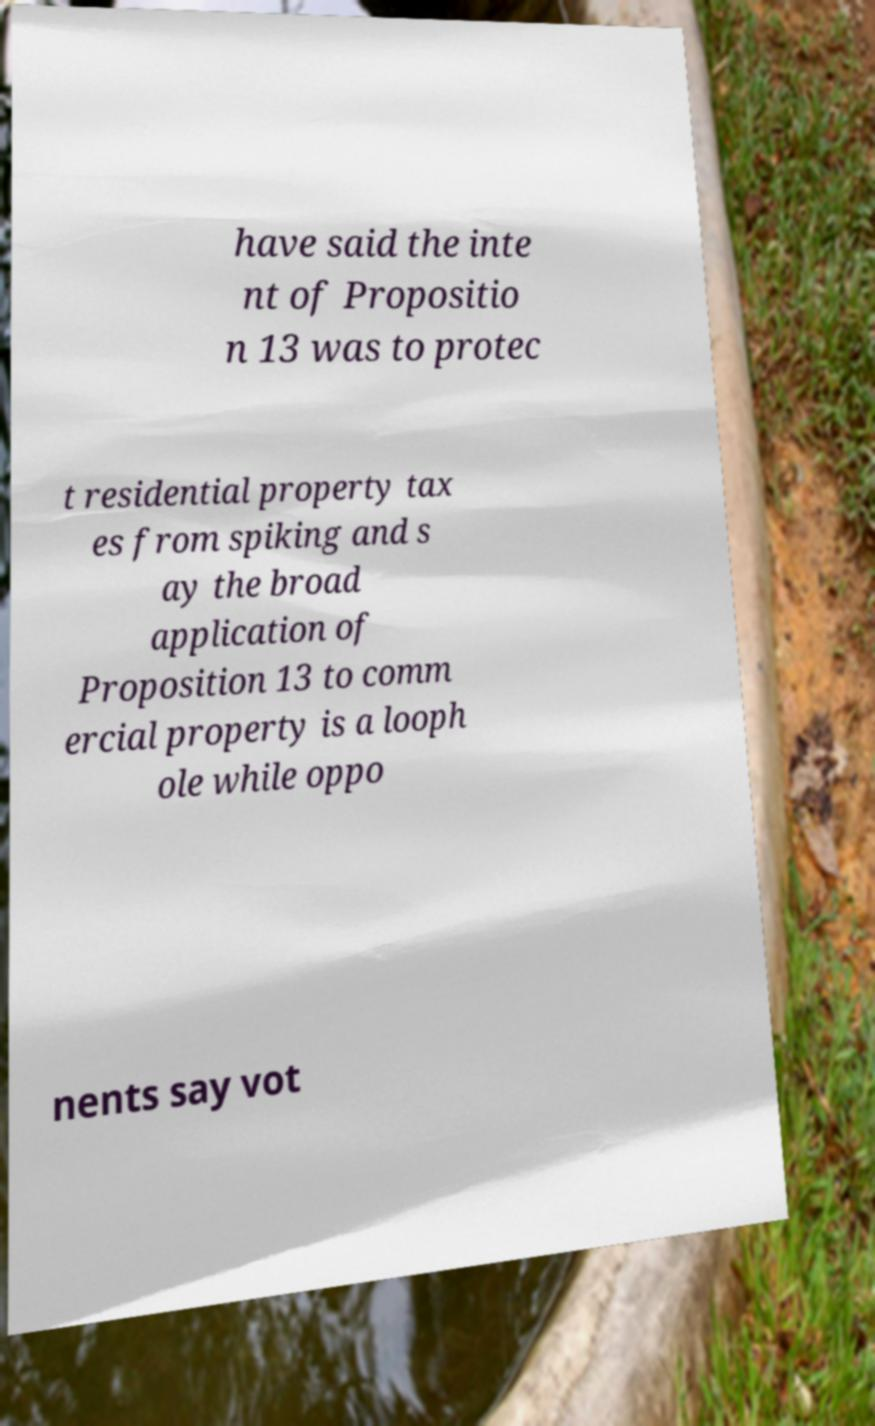For documentation purposes, I need the text within this image transcribed. Could you provide that? have said the inte nt of Propositio n 13 was to protec t residential property tax es from spiking and s ay the broad application of Proposition 13 to comm ercial property is a looph ole while oppo nents say vot 